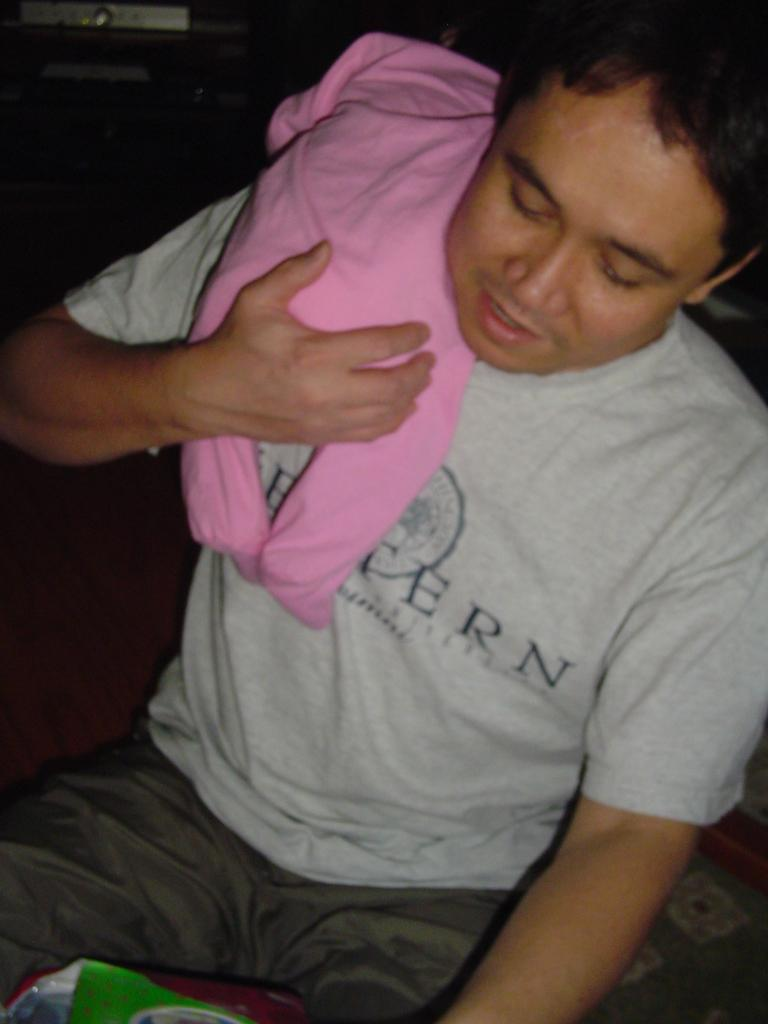What is happening in the center of the image? A: There is a person holding a baby in the center of the image. Can you describe the background of the image? There are objects in the background of the image. What type of cream or paste is being applied to the bushes in the image? There are no bushes, cream, or paste present in the image. 